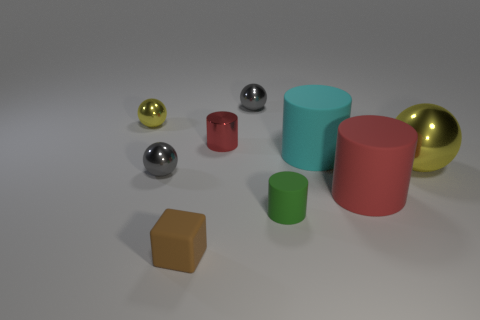Is there a small brown cube that has the same material as the cyan cylinder?
Provide a short and direct response. Yes. Is the size of the cyan rubber object the same as the brown matte cube?
Ensure brevity in your answer.  No. What number of spheres are tiny gray shiny objects or tiny green objects?
Provide a short and direct response. 2. What is the material of the other cylinder that is the same color as the small shiny cylinder?
Keep it short and to the point. Rubber. How many big cyan things have the same shape as the tiny green object?
Provide a succinct answer. 1. Is the number of brown rubber objects that are to the right of the small yellow sphere greater than the number of red matte cylinders that are behind the small red object?
Provide a succinct answer. Yes. There is a big rubber cylinder that is on the right side of the big cyan cylinder; is its color the same as the small metal cylinder?
Offer a terse response. Yes. The red matte cylinder has what size?
Offer a terse response. Large. There is a yellow thing that is the same size as the brown matte object; what is it made of?
Your answer should be compact. Metal. There is a small object that is in front of the small green cylinder; what color is it?
Offer a terse response. Brown. 